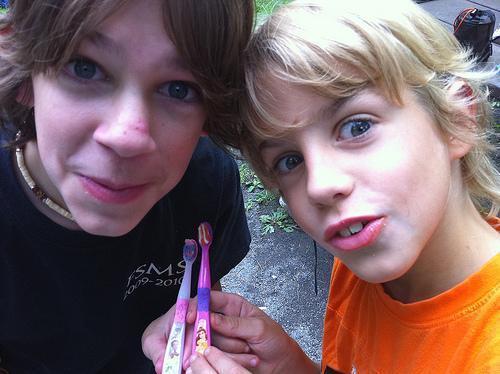How many toothbrushes are there?
Give a very brief answer. 2. 